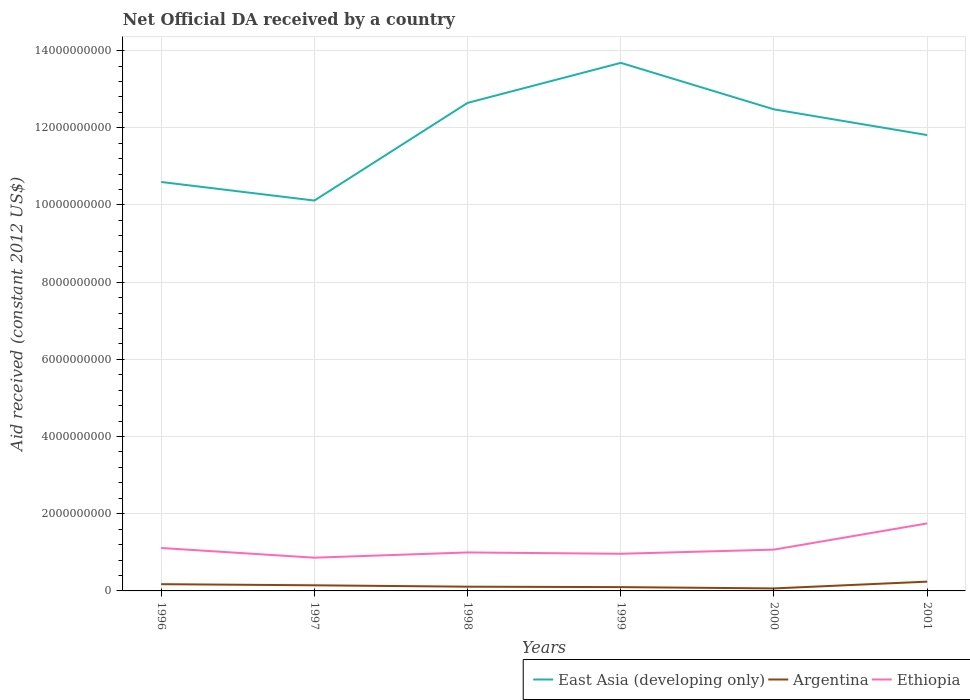Does the line corresponding to Ethiopia intersect with the line corresponding to Argentina?
Ensure brevity in your answer.  No. Across all years, what is the maximum net official development assistance aid received in Argentina?
Provide a short and direct response. 6.48e+07. What is the total net official development assistance aid received in Ethiopia in the graph?
Your answer should be compact. -6.37e+08. What is the difference between the highest and the second highest net official development assistance aid received in Ethiopia?
Keep it short and to the point. 8.88e+08. How many years are there in the graph?
Provide a succinct answer. 6. What is the difference between two consecutive major ticks on the Y-axis?
Offer a very short reply. 2.00e+09. Are the values on the major ticks of Y-axis written in scientific E-notation?
Give a very brief answer. No. Does the graph contain any zero values?
Your answer should be very brief. No. Does the graph contain grids?
Provide a succinct answer. Yes. How many legend labels are there?
Your answer should be very brief. 3. What is the title of the graph?
Your answer should be compact. Net Official DA received by a country. What is the label or title of the X-axis?
Provide a short and direct response. Years. What is the label or title of the Y-axis?
Your answer should be very brief. Aid received (constant 2012 US$). What is the Aid received (constant 2012 US$) of East Asia (developing only) in 1996?
Your answer should be compact. 1.06e+1. What is the Aid received (constant 2012 US$) in Argentina in 1996?
Your answer should be compact. 1.75e+08. What is the Aid received (constant 2012 US$) in Ethiopia in 1996?
Your answer should be compact. 1.11e+09. What is the Aid received (constant 2012 US$) of East Asia (developing only) in 1997?
Provide a succinct answer. 1.01e+1. What is the Aid received (constant 2012 US$) of Argentina in 1997?
Offer a very short reply. 1.46e+08. What is the Aid received (constant 2012 US$) of Ethiopia in 1997?
Ensure brevity in your answer.  8.61e+08. What is the Aid received (constant 2012 US$) of East Asia (developing only) in 1998?
Provide a succinct answer. 1.26e+1. What is the Aid received (constant 2012 US$) of Argentina in 1998?
Your answer should be compact. 1.10e+08. What is the Aid received (constant 2012 US$) of Ethiopia in 1998?
Keep it short and to the point. 9.97e+08. What is the Aid received (constant 2012 US$) of East Asia (developing only) in 1999?
Your response must be concise. 1.37e+1. What is the Aid received (constant 2012 US$) in Argentina in 1999?
Your answer should be very brief. 9.90e+07. What is the Aid received (constant 2012 US$) in Ethiopia in 1999?
Make the answer very short. 9.62e+08. What is the Aid received (constant 2012 US$) of East Asia (developing only) in 2000?
Provide a short and direct response. 1.25e+1. What is the Aid received (constant 2012 US$) of Argentina in 2000?
Offer a terse response. 6.48e+07. What is the Aid received (constant 2012 US$) in Ethiopia in 2000?
Keep it short and to the point. 1.07e+09. What is the Aid received (constant 2012 US$) in East Asia (developing only) in 2001?
Offer a terse response. 1.18e+1. What is the Aid received (constant 2012 US$) of Argentina in 2001?
Provide a succinct answer. 2.41e+08. What is the Aid received (constant 2012 US$) in Ethiopia in 2001?
Ensure brevity in your answer.  1.75e+09. Across all years, what is the maximum Aid received (constant 2012 US$) in East Asia (developing only)?
Keep it short and to the point. 1.37e+1. Across all years, what is the maximum Aid received (constant 2012 US$) of Argentina?
Keep it short and to the point. 2.41e+08. Across all years, what is the maximum Aid received (constant 2012 US$) in Ethiopia?
Make the answer very short. 1.75e+09. Across all years, what is the minimum Aid received (constant 2012 US$) in East Asia (developing only)?
Your response must be concise. 1.01e+1. Across all years, what is the minimum Aid received (constant 2012 US$) of Argentina?
Provide a short and direct response. 6.48e+07. Across all years, what is the minimum Aid received (constant 2012 US$) of Ethiopia?
Make the answer very short. 8.61e+08. What is the total Aid received (constant 2012 US$) of East Asia (developing only) in the graph?
Make the answer very short. 7.13e+1. What is the total Aid received (constant 2012 US$) of Argentina in the graph?
Your response must be concise. 8.34e+08. What is the total Aid received (constant 2012 US$) of Ethiopia in the graph?
Offer a terse response. 6.75e+09. What is the difference between the Aid received (constant 2012 US$) in East Asia (developing only) in 1996 and that in 1997?
Provide a succinct answer. 4.82e+08. What is the difference between the Aid received (constant 2012 US$) in Argentina in 1996 and that in 1997?
Offer a terse response. 2.92e+07. What is the difference between the Aid received (constant 2012 US$) in Ethiopia in 1996 and that in 1997?
Offer a very short reply. 2.51e+08. What is the difference between the Aid received (constant 2012 US$) in East Asia (developing only) in 1996 and that in 1998?
Your answer should be compact. -2.05e+09. What is the difference between the Aid received (constant 2012 US$) in Argentina in 1996 and that in 1998?
Make the answer very short. 6.53e+07. What is the difference between the Aid received (constant 2012 US$) in Ethiopia in 1996 and that in 1998?
Ensure brevity in your answer.  1.15e+08. What is the difference between the Aid received (constant 2012 US$) of East Asia (developing only) in 1996 and that in 1999?
Your answer should be very brief. -3.09e+09. What is the difference between the Aid received (constant 2012 US$) in Argentina in 1996 and that in 1999?
Offer a terse response. 7.59e+07. What is the difference between the Aid received (constant 2012 US$) in Ethiopia in 1996 and that in 1999?
Your answer should be compact. 1.50e+08. What is the difference between the Aid received (constant 2012 US$) of East Asia (developing only) in 1996 and that in 2000?
Provide a succinct answer. -1.88e+09. What is the difference between the Aid received (constant 2012 US$) of Argentina in 1996 and that in 2000?
Your answer should be compact. 1.10e+08. What is the difference between the Aid received (constant 2012 US$) in Ethiopia in 1996 and that in 2000?
Your response must be concise. 4.19e+07. What is the difference between the Aid received (constant 2012 US$) in East Asia (developing only) in 1996 and that in 2001?
Your response must be concise. -1.22e+09. What is the difference between the Aid received (constant 2012 US$) of Argentina in 1996 and that in 2001?
Offer a very short reply. -6.57e+07. What is the difference between the Aid received (constant 2012 US$) of Ethiopia in 1996 and that in 2001?
Offer a very short reply. -6.37e+08. What is the difference between the Aid received (constant 2012 US$) of East Asia (developing only) in 1997 and that in 1998?
Provide a short and direct response. -2.53e+09. What is the difference between the Aid received (constant 2012 US$) in Argentina in 1997 and that in 1998?
Provide a succinct answer. 3.61e+07. What is the difference between the Aid received (constant 2012 US$) in Ethiopia in 1997 and that in 1998?
Ensure brevity in your answer.  -1.36e+08. What is the difference between the Aid received (constant 2012 US$) of East Asia (developing only) in 1997 and that in 1999?
Offer a terse response. -3.57e+09. What is the difference between the Aid received (constant 2012 US$) of Argentina in 1997 and that in 1999?
Give a very brief answer. 4.67e+07. What is the difference between the Aid received (constant 2012 US$) of Ethiopia in 1997 and that in 1999?
Give a very brief answer. -1.01e+08. What is the difference between the Aid received (constant 2012 US$) in East Asia (developing only) in 1997 and that in 2000?
Offer a terse response. -2.36e+09. What is the difference between the Aid received (constant 2012 US$) of Argentina in 1997 and that in 2000?
Make the answer very short. 8.08e+07. What is the difference between the Aid received (constant 2012 US$) in Ethiopia in 1997 and that in 2000?
Offer a terse response. -2.09e+08. What is the difference between the Aid received (constant 2012 US$) of East Asia (developing only) in 1997 and that in 2001?
Your response must be concise. -1.70e+09. What is the difference between the Aid received (constant 2012 US$) in Argentina in 1997 and that in 2001?
Your answer should be very brief. -9.49e+07. What is the difference between the Aid received (constant 2012 US$) in Ethiopia in 1997 and that in 2001?
Provide a succinct answer. -8.88e+08. What is the difference between the Aid received (constant 2012 US$) in East Asia (developing only) in 1998 and that in 1999?
Provide a succinct answer. -1.04e+09. What is the difference between the Aid received (constant 2012 US$) in Argentina in 1998 and that in 1999?
Your answer should be compact. 1.06e+07. What is the difference between the Aid received (constant 2012 US$) in Ethiopia in 1998 and that in 1999?
Provide a short and direct response. 3.46e+07. What is the difference between the Aid received (constant 2012 US$) of East Asia (developing only) in 1998 and that in 2000?
Make the answer very short. 1.68e+08. What is the difference between the Aid received (constant 2012 US$) of Argentina in 1998 and that in 2000?
Give a very brief answer. 4.47e+07. What is the difference between the Aid received (constant 2012 US$) of Ethiopia in 1998 and that in 2000?
Provide a succinct answer. -7.33e+07. What is the difference between the Aid received (constant 2012 US$) in East Asia (developing only) in 1998 and that in 2001?
Ensure brevity in your answer.  8.34e+08. What is the difference between the Aid received (constant 2012 US$) in Argentina in 1998 and that in 2001?
Keep it short and to the point. -1.31e+08. What is the difference between the Aid received (constant 2012 US$) of Ethiopia in 1998 and that in 2001?
Ensure brevity in your answer.  -7.52e+08. What is the difference between the Aid received (constant 2012 US$) of East Asia (developing only) in 1999 and that in 2000?
Offer a very short reply. 1.21e+09. What is the difference between the Aid received (constant 2012 US$) of Argentina in 1999 and that in 2000?
Make the answer very short. 3.41e+07. What is the difference between the Aid received (constant 2012 US$) in Ethiopia in 1999 and that in 2000?
Offer a very short reply. -1.08e+08. What is the difference between the Aid received (constant 2012 US$) in East Asia (developing only) in 1999 and that in 2001?
Keep it short and to the point. 1.87e+09. What is the difference between the Aid received (constant 2012 US$) of Argentina in 1999 and that in 2001?
Your answer should be compact. -1.42e+08. What is the difference between the Aid received (constant 2012 US$) of Ethiopia in 1999 and that in 2001?
Your answer should be very brief. -7.87e+08. What is the difference between the Aid received (constant 2012 US$) in East Asia (developing only) in 2000 and that in 2001?
Your answer should be very brief. 6.66e+08. What is the difference between the Aid received (constant 2012 US$) in Argentina in 2000 and that in 2001?
Provide a succinct answer. -1.76e+08. What is the difference between the Aid received (constant 2012 US$) of Ethiopia in 2000 and that in 2001?
Ensure brevity in your answer.  -6.79e+08. What is the difference between the Aid received (constant 2012 US$) of East Asia (developing only) in 1996 and the Aid received (constant 2012 US$) of Argentina in 1997?
Keep it short and to the point. 1.05e+1. What is the difference between the Aid received (constant 2012 US$) of East Asia (developing only) in 1996 and the Aid received (constant 2012 US$) of Ethiopia in 1997?
Your answer should be compact. 9.73e+09. What is the difference between the Aid received (constant 2012 US$) in Argentina in 1996 and the Aid received (constant 2012 US$) in Ethiopia in 1997?
Provide a short and direct response. -6.86e+08. What is the difference between the Aid received (constant 2012 US$) in East Asia (developing only) in 1996 and the Aid received (constant 2012 US$) in Argentina in 1998?
Keep it short and to the point. 1.05e+1. What is the difference between the Aid received (constant 2012 US$) in East Asia (developing only) in 1996 and the Aid received (constant 2012 US$) in Ethiopia in 1998?
Your answer should be very brief. 9.60e+09. What is the difference between the Aid received (constant 2012 US$) of Argentina in 1996 and the Aid received (constant 2012 US$) of Ethiopia in 1998?
Your answer should be compact. -8.22e+08. What is the difference between the Aid received (constant 2012 US$) in East Asia (developing only) in 1996 and the Aid received (constant 2012 US$) in Argentina in 1999?
Keep it short and to the point. 1.05e+1. What is the difference between the Aid received (constant 2012 US$) of East Asia (developing only) in 1996 and the Aid received (constant 2012 US$) of Ethiopia in 1999?
Offer a very short reply. 9.63e+09. What is the difference between the Aid received (constant 2012 US$) of Argentina in 1996 and the Aid received (constant 2012 US$) of Ethiopia in 1999?
Give a very brief answer. -7.87e+08. What is the difference between the Aid received (constant 2012 US$) in East Asia (developing only) in 1996 and the Aid received (constant 2012 US$) in Argentina in 2000?
Provide a succinct answer. 1.05e+1. What is the difference between the Aid received (constant 2012 US$) of East Asia (developing only) in 1996 and the Aid received (constant 2012 US$) of Ethiopia in 2000?
Provide a short and direct response. 9.53e+09. What is the difference between the Aid received (constant 2012 US$) of Argentina in 1996 and the Aid received (constant 2012 US$) of Ethiopia in 2000?
Provide a succinct answer. -8.95e+08. What is the difference between the Aid received (constant 2012 US$) in East Asia (developing only) in 1996 and the Aid received (constant 2012 US$) in Argentina in 2001?
Give a very brief answer. 1.04e+1. What is the difference between the Aid received (constant 2012 US$) in East Asia (developing only) in 1996 and the Aid received (constant 2012 US$) in Ethiopia in 2001?
Your answer should be very brief. 8.85e+09. What is the difference between the Aid received (constant 2012 US$) in Argentina in 1996 and the Aid received (constant 2012 US$) in Ethiopia in 2001?
Provide a short and direct response. -1.57e+09. What is the difference between the Aid received (constant 2012 US$) in East Asia (developing only) in 1997 and the Aid received (constant 2012 US$) in Argentina in 1998?
Offer a terse response. 1.00e+1. What is the difference between the Aid received (constant 2012 US$) in East Asia (developing only) in 1997 and the Aid received (constant 2012 US$) in Ethiopia in 1998?
Your answer should be compact. 9.12e+09. What is the difference between the Aid received (constant 2012 US$) of Argentina in 1997 and the Aid received (constant 2012 US$) of Ethiopia in 1998?
Make the answer very short. -8.51e+08. What is the difference between the Aid received (constant 2012 US$) of East Asia (developing only) in 1997 and the Aid received (constant 2012 US$) of Argentina in 1999?
Offer a terse response. 1.00e+1. What is the difference between the Aid received (constant 2012 US$) in East Asia (developing only) in 1997 and the Aid received (constant 2012 US$) in Ethiopia in 1999?
Provide a succinct answer. 9.15e+09. What is the difference between the Aid received (constant 2012 US$) of Argentina in 1997 and the Aid received (constant 2012 US$) of Ethiopia in 1999?
Offer a very short reply. -8.17e+08. What is the difference between the Aid received (constant 2012 US$) in East Asia (developing only) in 1997 and the Aid received (constant 2012 US$) in Argentina in 2000?
Offer a very short reply. 1.00e+1. What is the difference between the Aid received (constant 2012 US$) of East Asia (developing only) in 1997 and the Aid received (constant 2012 US$) of Ethiopia in 2000?
Offer a terse response. 9.04e+09. What is the difference between the Aid received (constant 2012 US$) of Argentina in 1997 and the Aid received (constant 2012 US$) of Ethiopia in 2000?
Provide a short and direct response. -9.24e+08. What is the difference between the Aid received (constant 2012 US$) of East Asia (developing only) in 1997 and the Aid received (constant 2012 US$) of Argentina in 2001?
Provide a succinct answer. 9.87e+09. What is the difference between the Aid received (constant 2012 US$) in East Asia (developing only) in 1997 and the Aid received (constant 2012 US$) in Ethiopia in 2001?
Provide a short and direct response. 8.36e+09. What is the difference between the Aid received (constant 2012 US$) of Argentina in 1997 and the Aid received (constant 2012 US$) of Ethiopia in 2001?
Your answer should be very brief. -1.60e+09. What is the difference between the Aid received (constant 2012 US$) of East Asia (developing only) in 1998 and the Aid received (constant 2012 US$) of Argentina in 1999?
Ensure brevity in your answer.  1.25e+1. What is the difference between the Aid received (constant 2012 US$) in East Asia (developing only) in 1998 and the Aid received (constant 2012 US$) in Ethiopia in 1999?
Provide a succinct answer. 1.17e+1. What is the difference between the Aid received (constant 2012 US$) in Argentina in 1998 and the Aid received (constant 2012 US$) in Ethiopia in 1999?
Provide a short and direct response. -8.53e+08. What is the difference between the Aid received (constant 2012 US$) in East Asia (developing only) in 1998 and the Aid received (constant 2012 US$) in Argentina in 2000?
Your response must be concise. 1.26e+1. What is the difference between the Aid received (constant 2012 US$) of East Asia (developing only) in 1998 and the Aid received (constant 2012 US$) of Ethiopia in 2000?
Keep it short and to the point. 1.16e+1. What is the difference between the Aid received (constant 2012 US$) of Argentina in 1998 and the Aid received (constant 2012 US$) of Ethiopia in 2000?
Offer a very short reply. -9.61e+08. What is the difference between the Aid received (constant 2012 US$) in East Asia (developing only) in 1998 and the Aid received (constant 2012 US$) in Argentina in 2001?
Your answer should be very brief. 1.24e+1. What is the difference between the Aid received (constant 2012 US$) of East Asia (developing only) in 1998 and the Aid received (constant 2012 US$) of Ethiopia in 2001?
Provide a short and direct response. 1.09e+1. What is the difference between the Aid received (constant 2012 US$) in Argentina in 1998 and the Aid received (constant 2012 US$) in Ethiopia in 2001?
Provide a succinct answer. -1.64e+09. What is the difference between the Aid received (constant 2012 US$) of East Asia (developing only) in 1999 and the Aid received (constant 2012 US$) of Argentina in 2000?
Provide a succinct answer. 1.36e+1. What is the difference between the Aid received (constant 2012 US$) of East Asia (developing only) in 1999 and the Aid received (constant 2012 US$) of Ethiopia in 2000?
Your response must be concise. 1.26e+1. What is the difference between the Aid received (constant 2012 US$) of Argentina in 1999 and the Aid received (constant 2012 US$) of Ethiopia in 2000?
Your answer should be compact. -9.71e+08. What is the difference between the Aid received (constant 2012 US$) in East Asia (developing only) in 1999 and the Aid received (constant 2012 US$) in Argentina in 2001?
Make the answer very short. 1.34e+1. What is the difference between the Aid received (constant 2012 US$) in East Asia (developing only) in 1999 and the Aid received (constant 2012 US$) in Ethiopia in 2001?
Provide a succinct answer. 1.19e+1. What is the difference between the Aid received (constant 2012 US$) in Argentina in 1999 and the Aid received (constant 2012 US$) in Ethiopia in 2001?
Your response must be concise. -1.65e+09. What is the difference between the Aid received (constant 2012 US$) in East Asia (developing only) in 2000 and the Aid received (constant 2012 US$) in Argentina in 2001?
Offer a terse response. 1.22e+1. What is the difference between the Aid received (constant 2012 US$) in East Asia (developing only) in 2000 and the Aid received (constant 2012 US$) in Ethiopia in 2001?
Provide a short and direct response. 1.07e+1. What is the difference between the Aid received (constant 2012 US$) of Argentina in 2000 and the Aid received (constant 2012 US$) of Ethiopia in 2001?
Provide a succinct answer. -1.68e+09. What is the average Aid received (constant 2012 US$) in East Asia (developing only) per year?
Offer a very short reply. 1.19e+1. What is the average Aid received (constant 2012 US$) of Argentina per year?
Give a very brief answer. 1.39e+08. What is the average Aid received (constant 2012 US$) in Ethiopia per year?
Your answer should be compact. 1.13e+09. In the year 1996, what is the difference between the Aid received (constant 2012 US$) of East Asia (developing only) and Aid received (constant 2012 US$) of Argentina?
Offer a terse response. 1.04e+1. In the year 1996, what is the difference between the Aid received (constant 2012 US$) of East Asia (developing only) and Aid received (constant 2012 US$) of Ethiopia?
Offer a terse response. 9.48e+09. In the year 1996, what is the difference between the Aid received (constant 2012 US$) in Argentina and Aid received (constant 2012 US$) in Ethiopia?
Give a very brief answer. -9.37e+08. In the year 1997, what is the difference between the Aid received (constant 2012 US$) of East Asia (developing only) and Aid received (constant 2012 US$) of Argentina?
Your answer should be compact. 9.97e+09. In the year 1997, what is the difference between the Aid received (constant 2012 US$) of East Asia (developing only) and Aid received (constant 2012 US$) of Ethiopia?
Make the answer very short. 9.25e+09. In the year 1997, what is the difference between the Aid received (constant 2012 US$) of Argentina and Aid received (constant 2012 US$) of Ethiopia?
Offer a very short reply. -7.15e+08. In the year 1998, what is the difference between the Aid received (constant 2012 US$) of East Asia (developing only) and Aid received (constant 2012 US$) of Argentina?
Give a very brief answer. 1.25e+1. In the year 1998, what is the difference between the Aid received (constant 2012 US$) of East Asia (developing only) and Aid received (constant 2012 US$) of Ethiopia?
Make the answer very short. 1.16e+1. In the year 1998, what is the difference between the Aid received (constant 2012 US$) of Argentina and Aid received (constant 2012 US$) of Ethiopia?
Make the answer very short. -8.87e+08. In the year 1999, what is the difference between the Aid received (constant 2012 US$) in East Asia (developing only) and Aid received (constant 2012 US$) in Argentina?
Your response must be concise. 1.36e+1. In the year 1999, what is the difference between the Aid received (constant 2012 US$) in East Asia (developing only) and Aid received (constant 2012 US$) in Ethiopia?
Offer a very short reply. 1.27e+1. In the year 1999, what is the difference between the Aid received (constant 2012 US$) in Argentina and Aid received (constant 2012 US$) in Ethiopia?
Provide a short and direct response. -8.63e+08. In the year 2000, what is the difference between the Aid received (constant 2012 US$) of East Asia (developing only) and Aid received (constant 2012 US$) of Argentina?
Ensure brevity in your answer.  1.24e+1. In the year 2000, what is the difference between the Aid received (constant 2012 US$) of East Asia (developing only) and Aid received (constant 2012 US$) of Ethiopia?
Keep it short and to the point. 1.14e+1. In the year 2000, what is the difference between the Aid received (constant 2012 US$) in Argentina and Aid received (constant 2012 US$) in Ethiopia?
Ensure brevity in your answer.  -1.01e+09. In the year 2001, what is the difference between the Aid received (constant 2012 US$) of East Asia (developing only) and Aid received (constant 2012 US$) of Argentina?
Your answer should be compact. 1.16e+1. In the year 2001, what is the difference between the Aid received (constant 2012 US$) of East Asia (developing only) and Aid received (constant 2012 US$) of Ethiopia?
Keep it short and to the point. 1.01e+1. In the year 2001, what is the difference between the Aid received (constant 2012 US$) in Argentina and Aid received (constant 2012 US$) in Ethiopia?
Your response must be concise. -1.51e+09. What is the ratio of the Aid received (constant 2012 US$) in East Asia (developing only) in 1996 to that in 1997?
Your response must be concise. 1.05. What is the ratio of the Aid received (constant 2012 US$) of Argentina in 1996 to that in 1997?
Your response must be concise. 1.2. What is the ratio of the Aid received (constant 2012 US$) in Ethiopia in 1996 to that in 1997?
Provide a short and direct response. 1.29. What is the ratio of the Aid received (constant 2012 US$) of East Asia (developing only) in 1996 to that in 1998?
Offer a terse response. 0.84. What is the ratio of the Aid received (constant 2012 US$) of Argentina in 1996 to that in 1998?
Provide a succinct answer. 1.6. What is the ratio of the Aid received (constant 2012 US$) in Ethiopia in 1996 to that in 1998?
Ensure brevity in your answer.  1.12. What is the ratio of the Aid received (constant 2012 US$) in East Asia (developing only) in 1996 to that in 1999?
Keep it short and to the point. 0.77. What is the ratio of the Aid received (constant 2012 US$) of Argentina in 1996 to that in 1999?
Provide a short and direct response. 1.77. What is the ratio of the Aid received (constant 2012 US$) of Ethiopia in 1996 to that in 1999?
Ensure brevity in your answer.  1.16. What is the ratio of the Aid received (constant 2012 US$) of East Asia (developing only) in 1996 to that in 2000?
Your answer should be very brief. 0.85. What is the ratio of the Aid received (constant 2012 US$) in Argentina in 1996 to that in 2000?
Your response must be concise. 2.7. What is the ratio of the Aid received (constant 2012 US$) of Ethiopia in 1996 to that in 2000?
Give a very brief answer. 1.04. What is the ratio of the Aid received (constant 2012 US$) of East Asia (developing only) in 1996 to that in 2001?
Ensure brevity in your answer.  0.9. What is the ratio of the Aid received (constant 2012 US$) in Argentina in 1996 to that in 2001?
Ensure brevity in your answer.  0.73. What is the ratio of the Aid received (constant 2012 US$) in Ethiopia in 1996 to that in 2001?
Make the answer very short. 0.64. What is the ratio of the Aid received (constant 2012 US$) in East Asia (developing only) in 1997 to that in 1998?
Offer a terse response. 0.8. What is the ratio of the Aid received (constant 2012 US$) in Argentina in 1997 to that in 1998?
Your answer should be compact. 1.33. What is the ratio of the Aid received (constant 2012 US$) in Ethiopia in 1997 to that in 1998?
Your answer should be very brief. 0.86. What is the ratio of the Aid received (constant 2012 US$) in East Asia (developing only) in 1997 to that in 1999?
Offer a terse response. 0.74. What is the ratio of the Aid received (constant 2012 US$) in Argentina in 1997 to that in 1999?
Make the answer very short. 1.47. What is the ratio of the Aid received (constant 2012 US$) of Ethiopia in 1997 to that in 1999?
Provide a short and direct response. 0.89. What is the ratio of the Aid received (constant 2012 US$) of East Asia (developing only) in 1997 to that in 2000?
Keep it short and to the point. 0.81. What is the ratio of the Aid received (constant 2012 US$) of Argentina in 1997 to that in 2000?
Keep it short and to the point. 2.25. What is the ratio of the Aid received (constant 2012 US$) in Ethiopia in 1997 to that in 2000?
Keep it short and to the point. 0.8. What is the ratio of the Aid received (constant 2012 US$) of East Asia (developing only) in 1997 to that in 2001?
Make the answer very short. 0.86. What is the ratio of the Aid received (constant 2012 US$) in Argentina in 1997 to that in 2001?
Make the answer very short. 0.61. What is the ratio of the Aid received (constant 2012 US$) of Ethiopia in 1997 to that in 2001?
Provide a succinct answer. 0.49. What is the ratio of the Aid received (constant 2012 US$) of East Asia (developing only) in 1998 to that in 1999?
Your response must be concise. 0.92. What is the ratio of the Aid received (constant 2012 US$) of Argentina in 1998 to that in 1999?
Provide a short and direct response. 1.11. What is the ratio of the Aid received (constant 2012 US$) of Ethiopia in 1998 to that in 1999?
Your answer should be very brief. 1.04. What is the ratio of the Aid received (constant 2012 US$) of East Asia (developing only) in 1998 to that in 2000?
Ensure brevity in your answer.  1.01. What is the ratio of the Aid received (constant 2012 US$) in Argentina in 1998 to that in 2000?
Your response must be concise. 1.69. What is the ratio of the Aid received (constant 2012 US$) in Ethiopia in 1998 to that in 2000?
Your answer should be compact. 0.93. What is the ratio of the Aid received (constant 2012 US$) in East Asia (developing only) in 1998 to that in 2001?
Your response must be concise. 1.07. What is the ratio of the Aid received (constant 2012 US$) of Argentina in 1998 to that in 2001?
Make the answer very short. 0.46. What is the ratio of the Aid received (constant 2012 US$) of Ethiopia in 1998 to that in 2001?
Offer a very short reply. 0.57. What is the ratio of the Aid received (constant 2012 US$) in East Asia (developing only) in 1999 to that in 2000?
Provide a short and direct response. 1.1. What is the ratio of the Aid received (constant 2012 US$) in Argentina in 1999 to that in 2000?
Offer a terse response. 1.53. What is the ratio of the Aid received (constant 2012 US$) of Ethiopia in 1999 to that in 2000?
Ensure brevity in your answer.  0.9. What is the ratio of the Aid received (constant 2012 US$) in East Asia (developing only) in 1999 to that in 2001?
Your response must be concise. 1.16. What is the ratio of the Aid received (constant 2012 US$) in Argentina in 1999 to that in 2001?
Make the answer very short. 0.41. What is the ratio of the Aid received (constant 2012 US$) of Ethiopia in 1999 to that in 2001?
Make the answer very short. 0.55. What is the ratio of the Aid received (constant 2012 US$) of East Asia (developing only) in 2000 to that in 2001?
Keep it short and to the point. 1.06. What is the ratio of the Aid received (constant 2012 US$) in Argentina in 2000 to that in 2001?
Offer a very short reply. 0.27. What is the ratio of the Aid received (constant 2012 US$) of Ethiopia in 2000 to that in 2001?
Provide a short and direct response. 0.61. What is the difference between the highest and the second highest Aid received (constant 2012 US$) in East Asia (developing only)?
Give a very brief answer. 1.04e+09. What is the difference between the highest and the second highest Aid received (constant 2012 US$) of Argentina?
Offer a terse response. 6.57e+07. What is the difference between the highest and the second highest Aid received (constant 2012 US$) in Ethiopia?
Keep it short and to the point. 6.37e+08. What is the difference between the highest and the lowest Aid received (constant 2012 US$) of East Asia (developing only)?
Your answer should be very brief. 3.57e+09. What is the difference between the highest and the lowest Aid received (constant 2012 US$) of Argentina?
Provide a short and direct response. 1.76e+08. What is the difference between the highest and the lowest Aid received (constant 2012 US$) of Ethiopia?
Your response must be concise. 8.88e+08. 